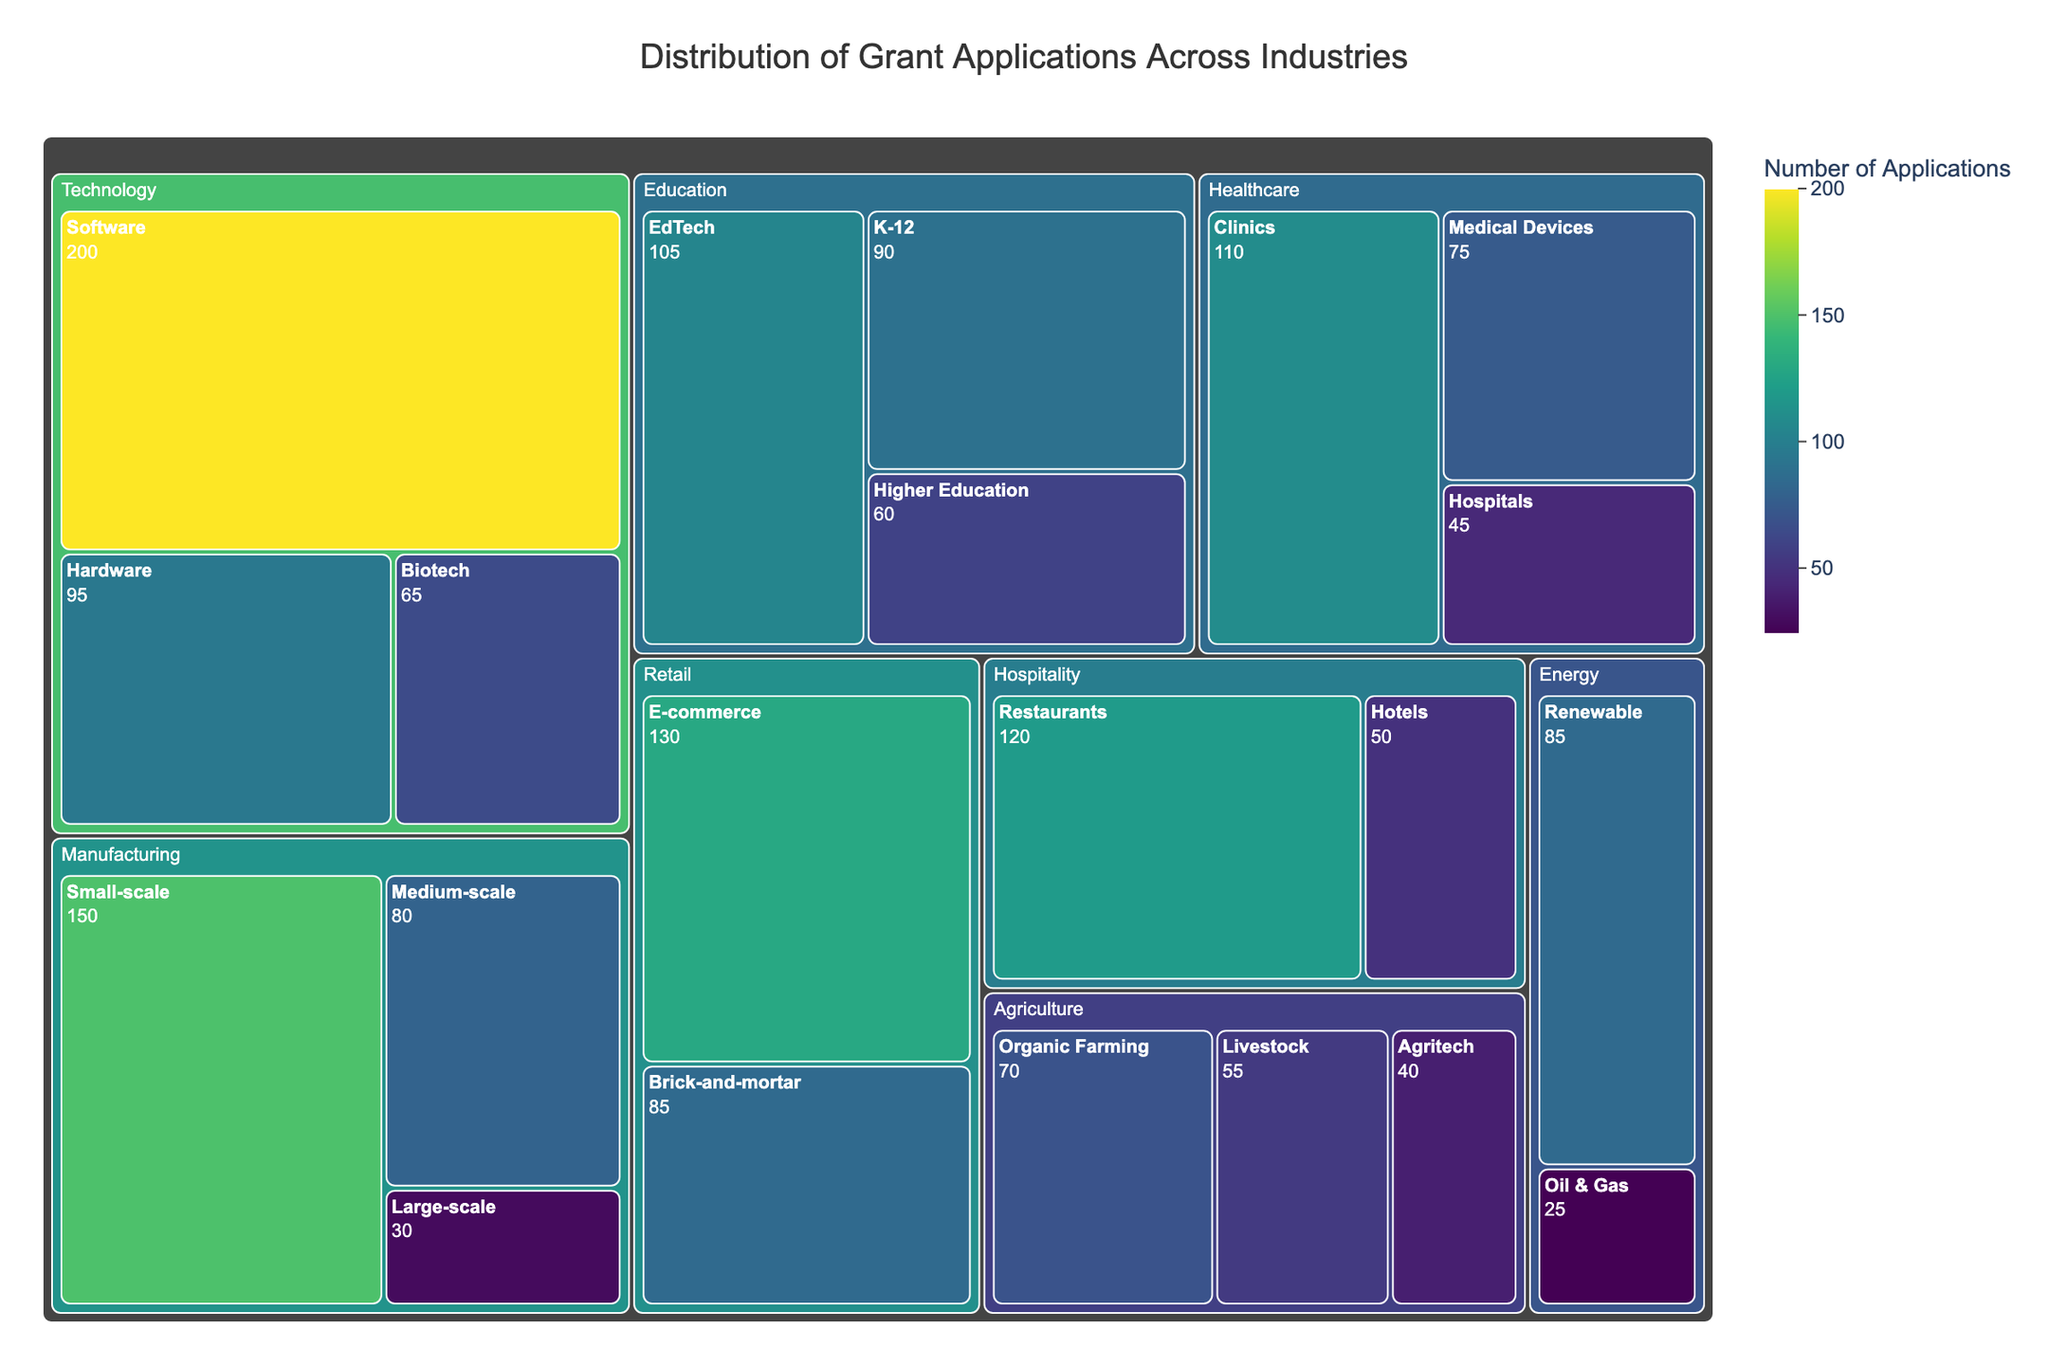What's the title of the treemap? The title is typically found at the top of the treemap and acts as a descriptor for what the visualization represents. Here, it is displayed prominently in a larger font.
Answer: Distribution of Grant Applications Across Industries Which industry has the highest number of applications in the treemap? By visually inspecting the size of the tiles and the values, we can see that the Technology sector, with a total of 360 applications (Software: 200, Hardware: 95, Biotech: 65), has the highest number of applications.
Answer: Technology How many applications are from the Healthcare industry in total? Sum the applications from all categories within Healthcare: Hospitals (45), Clinics (110), and Medical Devices (75). So, 45 + 110 + 75 = 230.
Answer: 230 What percentage of total applications does the Retail industry make up? First, calculate the total number of applications across all industries. Sum: 150+80+30+200+95+65+45+110+75+130+85+70+55+40+90+60+105+50+120+85+25 = 1765. Then, sum the applications from Retail: 130 (E-commerce) + 85 (Brick-and-mortar) = 215. Finally, divide 215 by 1765 and multiply by 100 to get the percentage: (215/1765) * 100 ≈ 12.17%.
Answer: Approximately 12.17% Which sub-category within Energy has the fewer applications? Observe within the Energy industry tile; there are two sub-categories, Renewable (85) and Oil & Gas (25). By comparing these numbers, Oil & Gas has fewer applications.
Answer: Oil & Gas Compare the number of applications from Restaurants in the Hospitality industry to Clinics in the Healthcare industry. Which has more? Restaurants in Hospitality have 120 applications, while Clinics in Healthcare have 110 applications. Thus, Restaurants have more applications.
Answer: Restaurants What's the average number of applications for the sub-categories within Agriculture? The sub-categories in Agriculture are Organic Farming (70), Livestock (55), and Agritech (40). The average is calculated as (70+55+40)/3 = 165/3 ≈ 55.
Answer: Approximately 55 Which sector has the least contribution in terms of the number of applications? By summing the categories within each industry and visually comparing the sizes of the tiles, Energy (Renewable: 85, Oil & Gas: 25) with a total of 110 applications appears to be the smallest sector overall.
Answer: Energy How many more applications does Software in Technology have compared to E-commerce in Retail? Software in Technology has 200 applications, whereas E-commerce in Retail has 130 applications. The difference is 200 - 130 = 70.
Answer: 70 Which sub-category in Manufacturing has the least number of applications? Within Manufacturing, compare the sub-categories: Small-scale (150), Medium-scale (80), and Large-scale (30). Large-scale, with 30 applications, has the least number.
Answer: Large-scale 